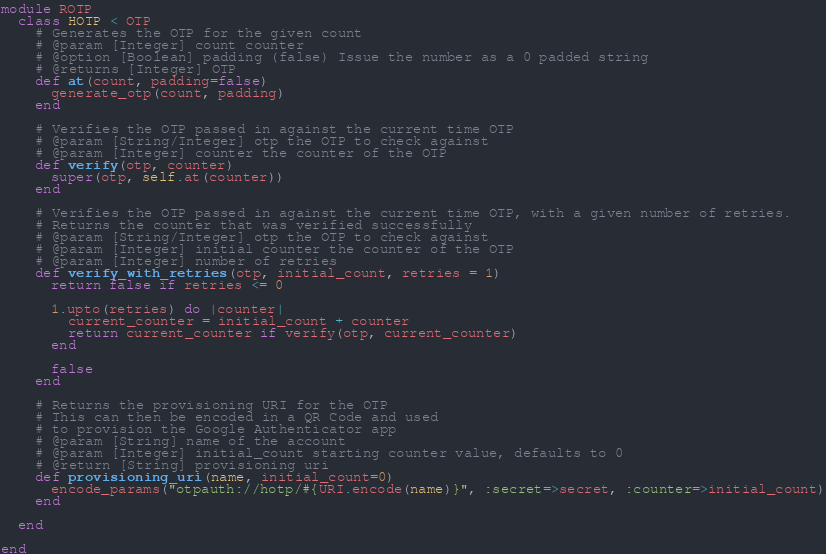Convert code to text. <code><loc_0><loc_0><loc_500><loc_500><_Ruby_>module ROTP
  class HOTP < OTP
    # Generates the OTP for the given count
    # @param [Integer] count counter
    # @option [Boolean] padding (false) Issue the number as a 0 padded string
    # @returns [Integer] OTP
    def at(count, padding=false)
      generate_otp(count, padding)
    end

    # Verifies the OTP passed in against the current time OTP
    # @param [String/Integer] otp the OTP to check against
    # @param [Integer] counter the counter of the OTP
    def verify(otp, counter)
      super(otp, self.at(counter))
    end

    # Verifies the OTP passed in against the current time OTP, with a given number of retries.
    # Returns the counter that was verified successfully
    # @param [String/Integer] otp the OTP to check against
    # @param [Integer] initial counter the counter of the OTP
    # @param [Integer] number of retries
    def verify_with_retries(otp, initial_count, retries = 1)
      return false if retries <= 0

      1.upto(retries) do |counter|
        current_counter = initial_count + counter
        return current_counter if verify(otp, current_counter)
      end

      false
    end

    # Returns the provisioning URI for the OTP
    # This can then be encoded in a QR Code and used
    # to provision the Google Authenticator app
    # @param [String] name of the account
    # @param [Integer] initial_count starting counter value, defaults to 0
    # @return [String] provisioning uri
    def provisioning_uri(name, initial_count=0)
      encode_params("otpauth://hotp/#{URI.encode(name)}", :secret=>secret, :counter=>initial_count)
    end

  end

end
</code> 